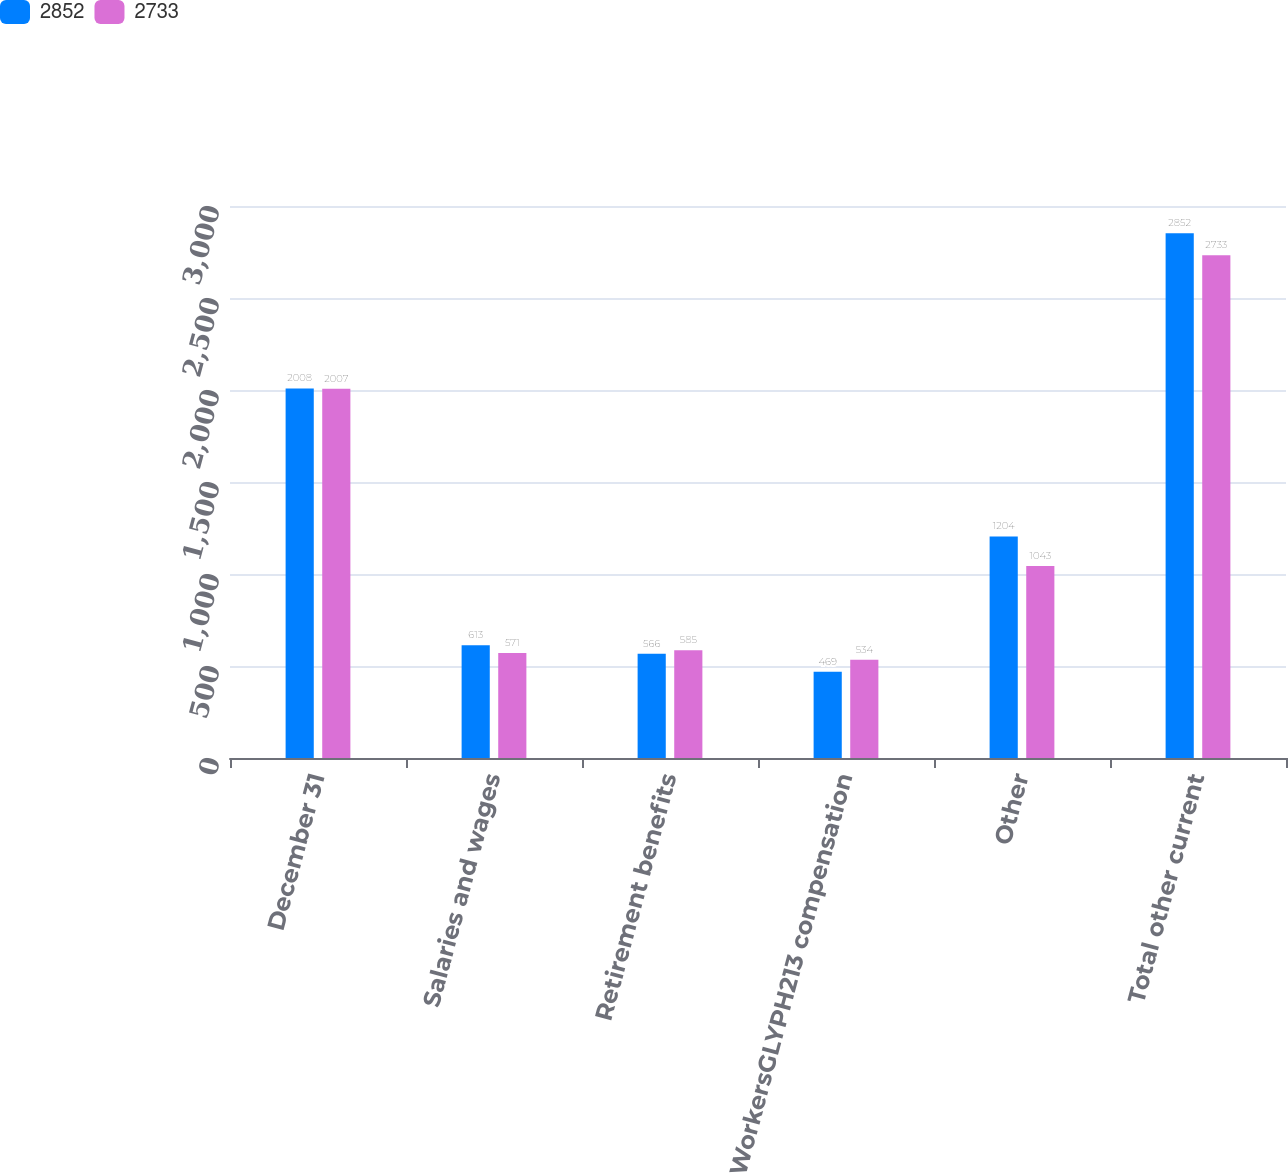<chart> <loc_0><loc_0><loc_500><loc_500><stacked_bar_chart><ecel><fcel>December 31<fcel>Salaries and wages<fcel>Retirement benefits<fcel>WorkersGLYPH213 compensation<fcel>Other<fcel>Total other current<nl><fcel>2852<fcel>2008<fcel>613<fcel>566<fcel>469<fcel>1204<fcel>2852<nl><fcel>2733<fcel>2007<fcel>571<fcel>585<fcel>534<fcel>1043<fcel>2733<nl></chart> 